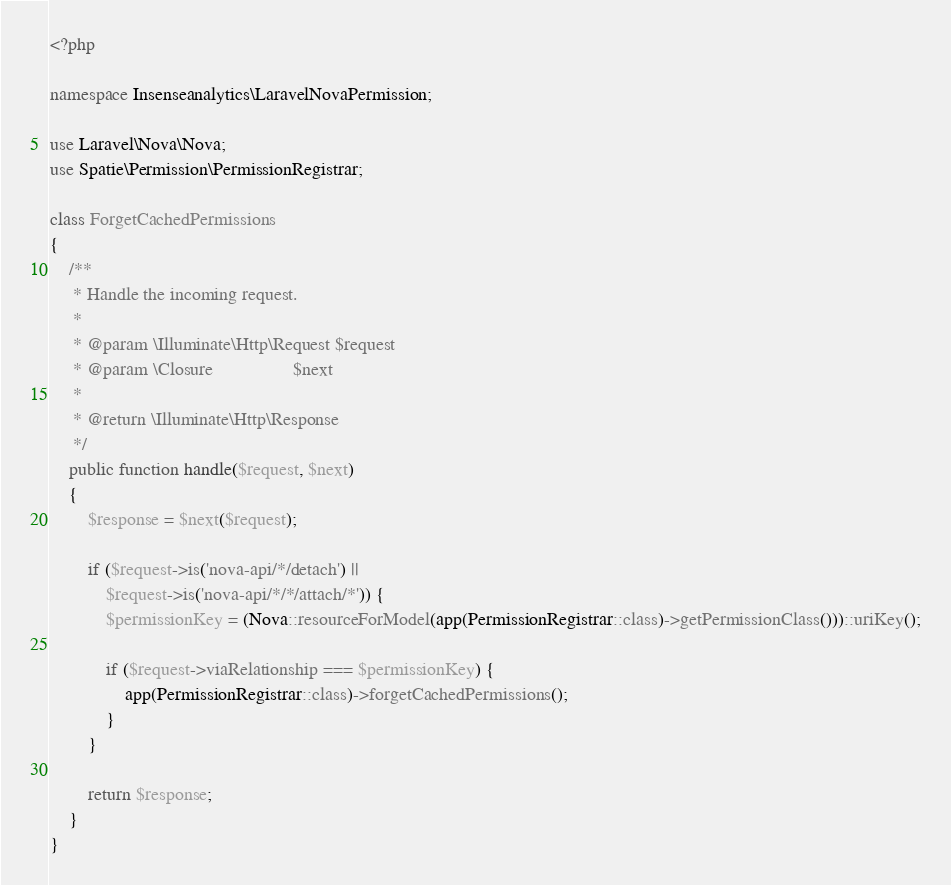Convert code to text. <code><loc_0><loc_0><loc_500><loc_500><_PHP_><?php

namespace Insenseanalytics\LaravelNovaPermission;

use Laravel\Nova\Nova;
use Spatie\Permission\PermissionRegistrar;

class ForgetCachedPermissions
{
	/**
	 * Handle the incoming request.
	 *
	 * @param \Illuminate\Http\Request $request
	 * @param \Closure                 $next
	 *
	 * @return \Illuminate\Http\Response
	 */
	public function handle($request, $next)
	{
		$response = $next($request);

		if ($request->is('nova-api/*/detach') ||
			$request->is('nova-api/*/*/attach/*')) {
			$permissionKey = (Nova::resourceForModel(app(PermissionRegistrar::class)->getPermissionClass()))::uriKey();

			if ($request->viaRelationship === $permissionKey) {
				app(PermissionRegistrar::class)->forgetCachedPermissions();
			}
		}

		return $response;
	}
}
</code> 